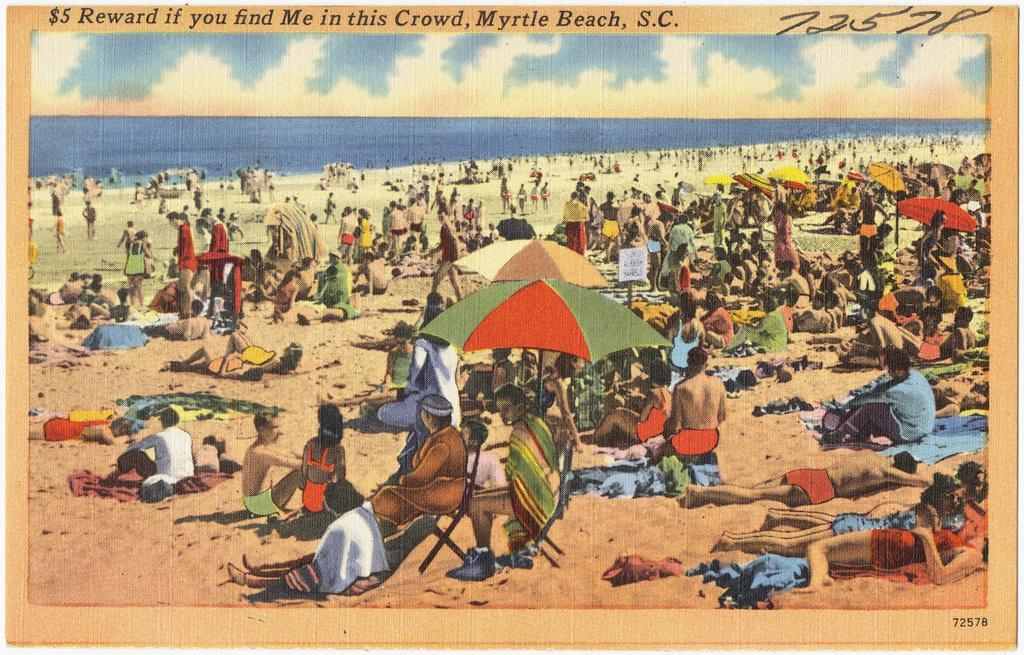How would you summarize this image in a sentence or two? In the image we can see the poster, in the poster we can see there are people sitting and some of them are lying, they are wearing clothes. Here we can see umbrellas and the rest chairs. Here we can see the sand, water and the sky. 